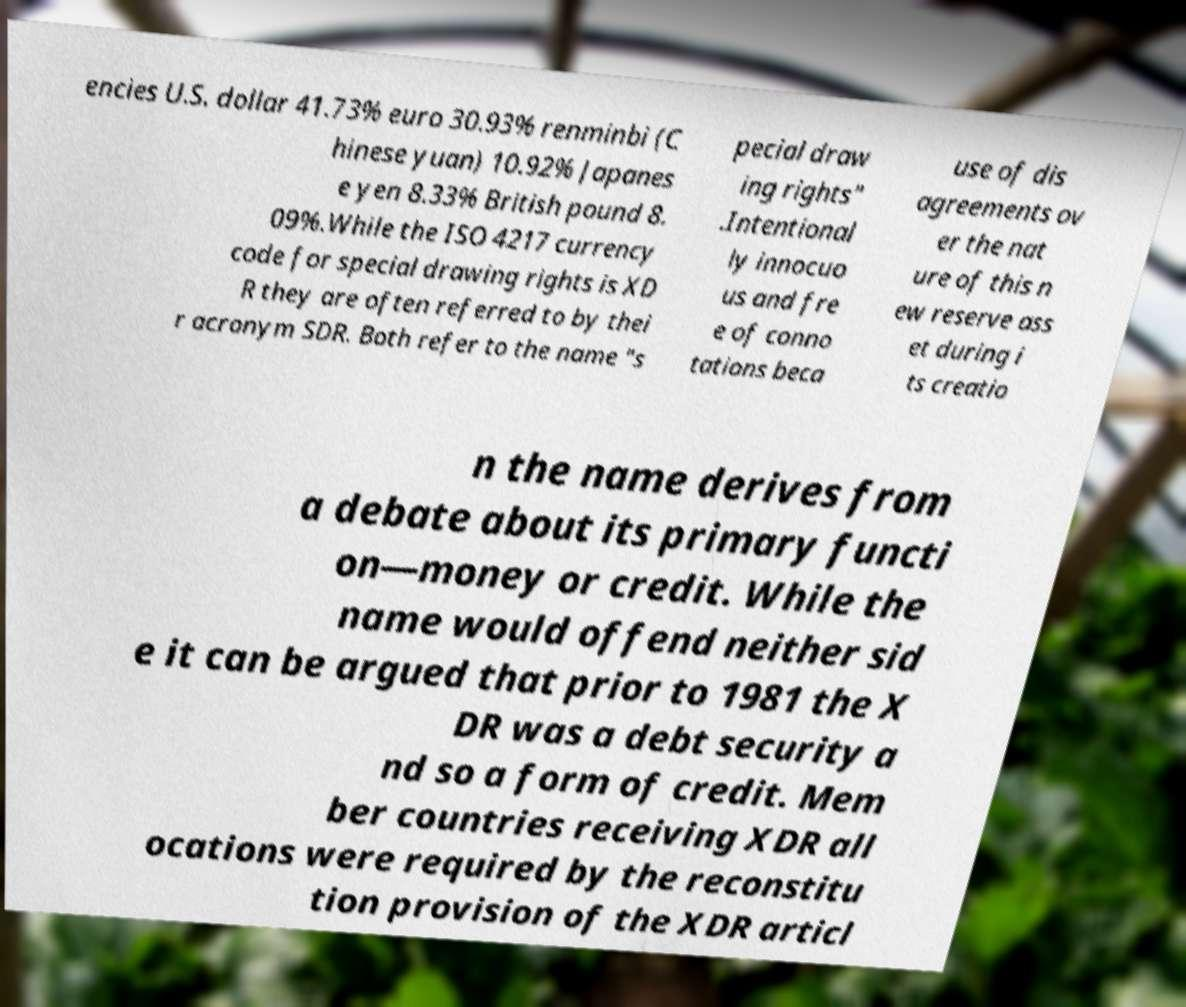I need the written content from this picture converted into text. Can you do that? encies U.S. dollar 41.73% euro 30.93% renminbi (C hinese yuan) 10.92% Japanes e yen 8.33% British pound 8. 09%.While the ISO 4217 currency code for special drawing rights is XD R they are often referred to by thei r acronym SDR. Both refer to the name "s pecial draw ing rights" .Intentional ly innocuo us and fre e of conno tations beca use of dis agreements ov er the nat ure of this n ew reserve ass et during i ts creatio n the name derives from a debate about its primary functi on—money or credit. While the name would offend neither sid e it can be argued that prior to 1981 the X DR was a debt security a nd so a form of credit. Mem ber countries receiving XDR all ocations were required by the reconstitu tion provision of the XDR articl 